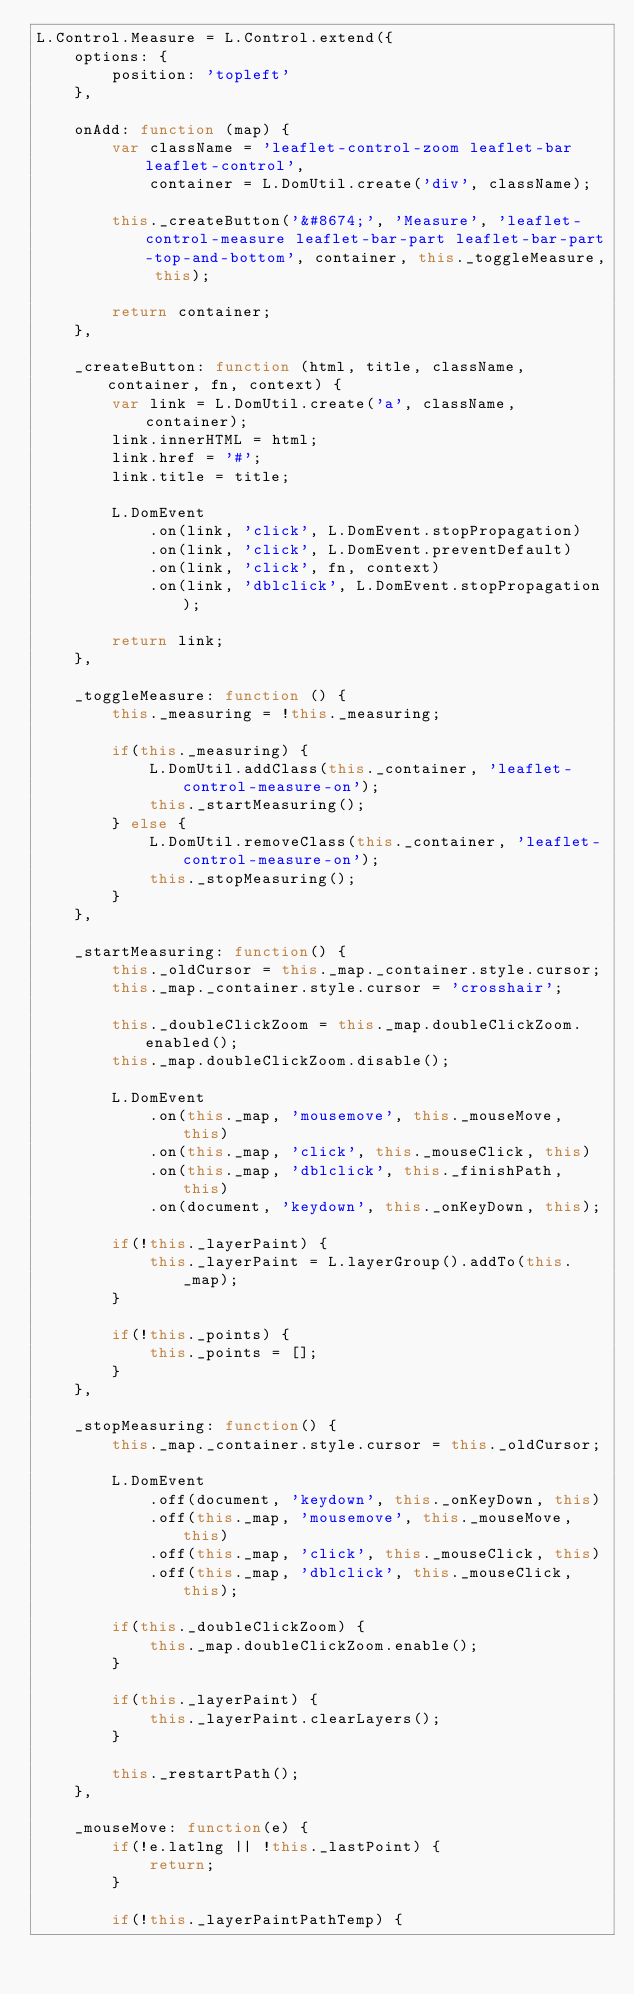<code> <loc_0><loc_0><loc_500><loc_500><_JavaScript_>L.Control.Measure = L.Control.extend({
	options: {
		position: 'topleft'
	},

	onAdd: function (map) {
		var className = 'leaflet-control-zoom leaflet-bar leaflet-control',
		    container = L.DomUtil.create('div', className);

		this._createButton('&#8674;', 'Measure', 'leaflet-control-measure leaflet-bar-part leaflet-bar-part-top-and-bottom', container, this._toggleMeasure, this);

		return container;
	},

	_createButton: function (html, title, className, container, fn, context) {
		var link = L.DomUtil.create('a', className, container);
		link.innerHTML = html;
		link.href = '#';
		link.title = title;

		L.DomEvent
			.on(link, 'click', L.DomEvent.stopPropagation)
			.on(link, 'click', L.DomEvent.preventDefault)
			.on(link, 'click', fn, context)
			.on(link, 'dblclick', L.DomEvent.stopPropagation);

		return link;
	},

	_toggleMeasure: function () {
		this._measuring = !this._measuring;

		if(this._measuring) {
			L.DomUtil.addClass(this._container, 'leaflet-control-measure-on');
			this._startMeasuring();
		} else {
			L.DomUtil.removeClass(this._container, 'leaflet-control-measure-on');
			this._stopMeasuring();
		}
	},

	_startMeasuring: function() {
		this._oldCursor = this._map._container.style.cursor;
		this._map._container.style.cursor = 'crosshair';

		this._doubleClickZoom = this._map.doubleClickZoom.enabled();
		this._map.doubleClickZoom.disable();

		L.DomEvent
			.on(this._map, 'mousemove', this._mouseMove, this)
			.on(this._map, 'click', this._mouseClick, this)
			.on(this._map, 'dblclick', this._finishPath, this)
			.on(document, 'keydown', this._onKeyDown, this);

		if(!this._layerPaint) {
			this._layerPaint = L.layerGroup().addTo(this._map);	
		}

		if(!this._points) {
			this._points = [];
		}
	},

	_stopMeasuring: function() {
		this._map._container.style.cursor = this._oldCursor;

		L.DomEvent
			.off(document, 'keydown', this._onKeyDown, this)
			.off(this._map, 'mousemove', this._mouseMove, this)
			.off(this._map, 'click', this._mouseClick, this)
			.off(this._map, 'dblclick', this._mouseClick, this);

		if(this._doubleClickZoom) {
			this._map.doubleClickZoom.enable();
		}

		if(this._layerPaint) {
			this._layerPaint.clearLayers();
		}
		
		this._restartPath();
	},

	_mouseMove: function(e) {
		if(!e.latlng || !this._lastPoint) {
			return;
		}
		
		if(!this._layerPaintPathTemp) {</code> 